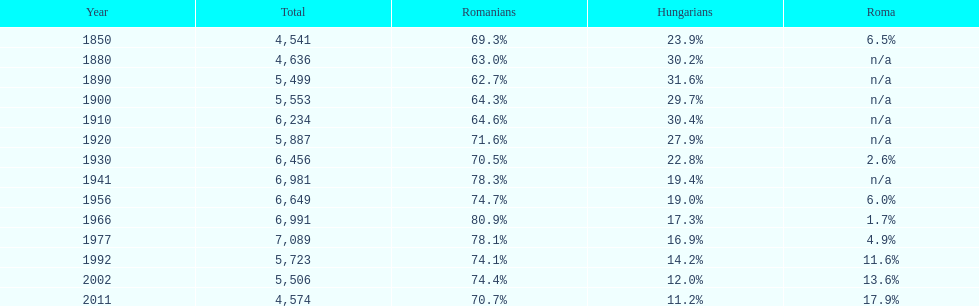In what year was the maximum percentage of hungarians recorded? 1890. 